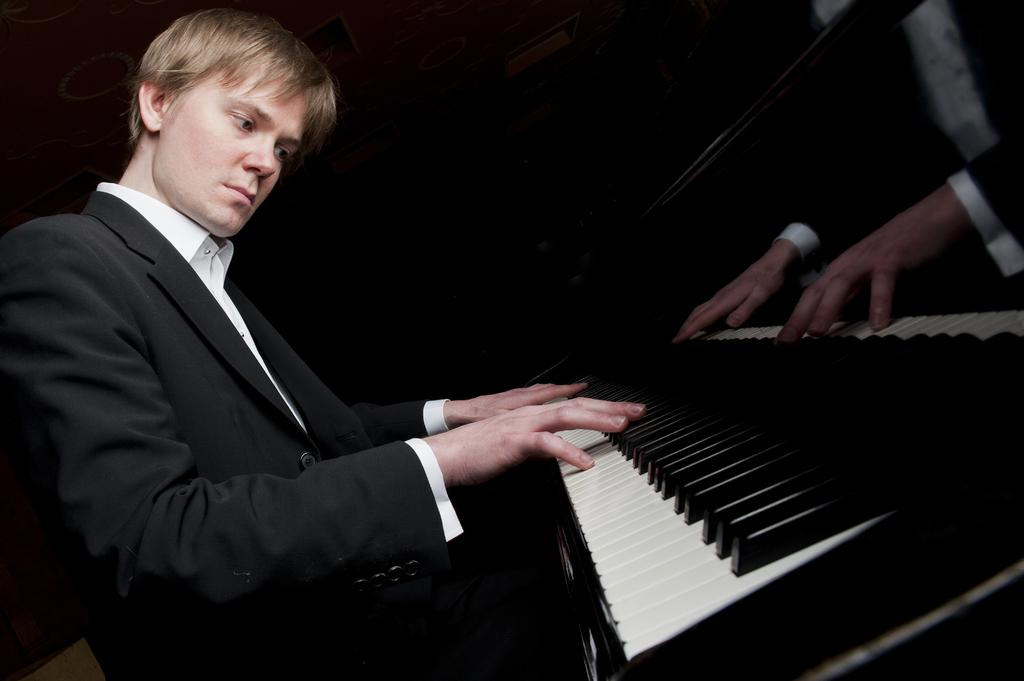Who is the main subject in the image? There is a man in the image. What is the man wearing? The man is wearing a white shirt and a black suit. What is the man doing in the image? The man is playing a piano. How many mice are sitting on the man's shoulder in the image? There are no mice present in the image. What role does the man's father play in the image? The facts provided do not mention the man's father, so we cannot determine his role in the image. 